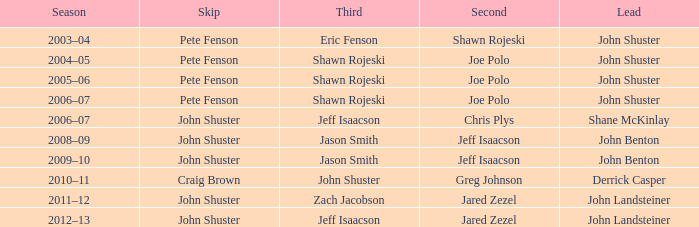Who was the lead with John Shuster as skip in the season of 2009–10? John Benton. 